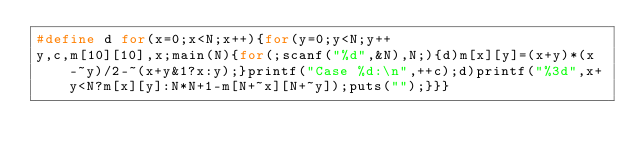Convert code to text. <code><loc_0><loc_0><loc_500><loc_500><_C_>#define d for(x=0;x<N;x++){for(y=0;y<N;y++
y,c,m[10][10],x;main(N){for(;scanf("%d",&N),N;){d)m[x][y]=(x+y)*(x-~y)/2-~(x+y&1?x:y);}printf("Case %d:\n",++c);d)printf("%3d",x+y<N?m[x][y]:N*N+1-m[N+~x][N+~y]);puts("");}}}</code> 